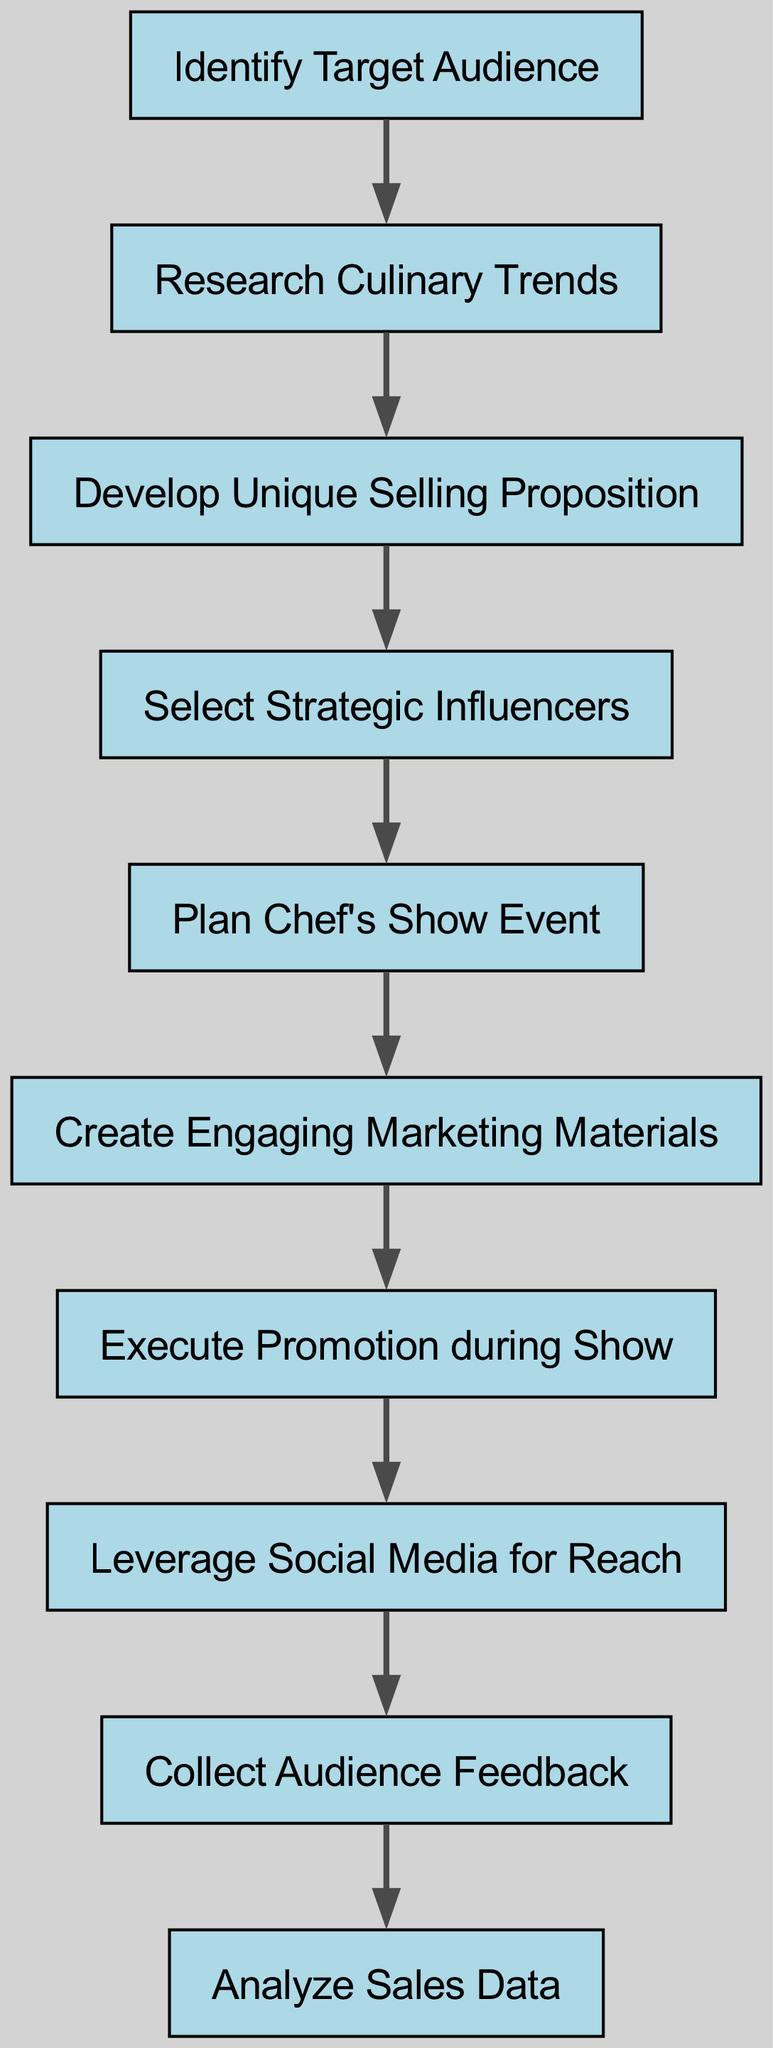What is the first step in the product promotion flow? The first step, as indicated by the node at the beginning of the diagram, is "Identify Target Audience."
Answer: Identify Target Audience How many nodes are present in the diagram? By counting the distinct elements labeled as nodes, we find there are a total of ten nodes in the diagram.
Answer: 10 What relationship exists between "Research Culinary Trends" and "Develop Unique Selling Proposition"? There is a directed edge from "Research Culinary Trends" to "Develop Unique Selling Proposition," indicating that researching trends informs the development of the unique selling proposition.
Answer: A directed edge Which node comes after "Plan Chef's Show Event"? The node directly connected to "Plan Chef's Show Event" in the flow is "Create Engaging Marketing Materials," indicating this is the next step in the sequence.
Answer: Create Engaging Marketing Materials What is the last step of the promotion flow? The final step in the diagram, shown as the last node, is "Analyze Sales Data," which concludes the promotion process.
Answer: Analyze Sales Data Which node leads to "Execute Promotion during Show"? The node "Create Engaging Marketing Materials" has a directed edge leading to "Execute Promotion during Show," indicating the workflow from marketing creation to execution.
Answer: Create Engaging Marketing Materials How does "Leverage Social Media for Reach" relate to "Execute Promotion during Show"? "Leverage Social Media for Reach" follows after "Execute Promotion during Show," demonstrating that social media efforts are utilized after the show to enhance outreach.
Answer: Follows after What is the total number of directed edges in the diagram? By analyzing the connections between the nodes, there are nine directed edges connecting the ten nodes, illustrating the flow of the promotion steps.
Answer: 9 Which step includes collecting audience feedback? The step dedicated to collecting feedback from the audience is "Collect Audience Feedback," which is positioned in the sequence to follow the social media efforts.
Answer: Collect Audience Feedback 